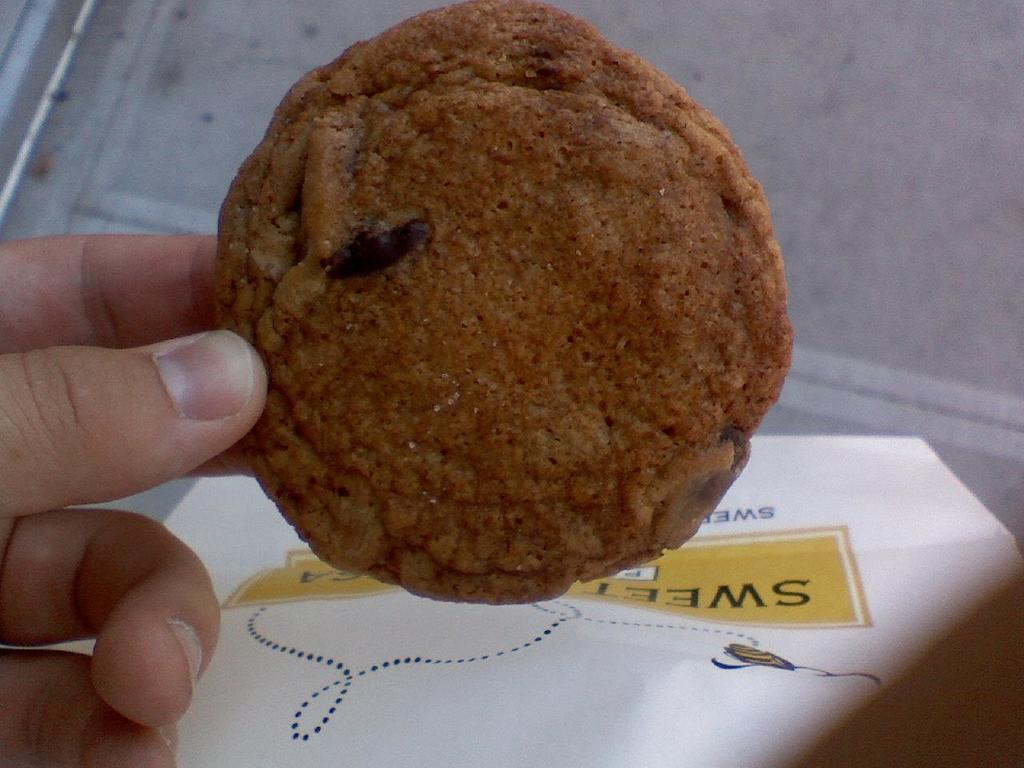What is the person's hand holding in the image? There is a person's hand holding a food item in the image. What else can be seen in the image besides the hand and the food item? There is a paper with some text in the image. What type of honey is being poured from the box in the image? There is no box or honey present in the image; it only features a person's hand holding a food item and a paper with text. 